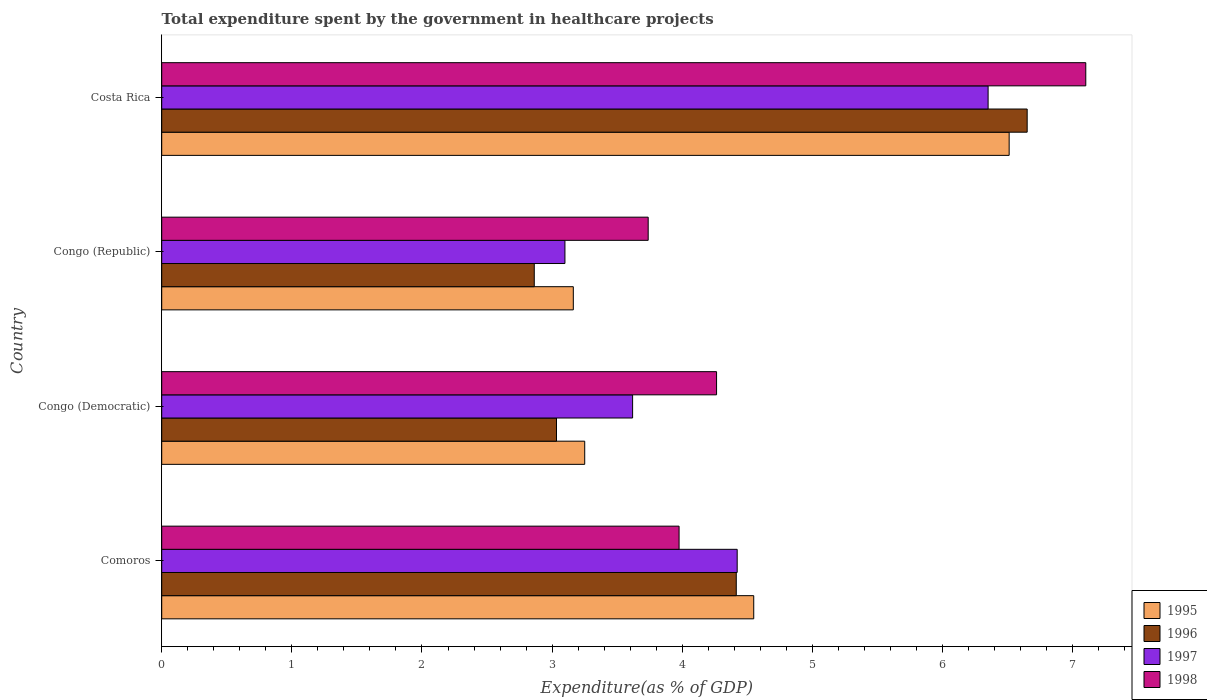How many different coloured bars are there?
Your response must be concise. 4. How many bars are there on the 3rd tick from the top?
Your answer should be compact. 4. How many bars are there on the 1st tick from the bottom?
Give a very brief answer. 4. What is the label of the 2nd group of bars from the top?
Keep it short and to the point. Congo (Republic). What is the total expenditure spent by the government in healthcare projects in 1995 in Congo (Democratic)?
Give a very brief answer. 3.25. Across all countries, what is the maximum total expenditure spent by the government in healthcare projects in 1998?
Give a very brief answer. 7.1. Across all countries, what is the minimum total expenditure spent by the government in healthcare projects in 1996?
Keep it short and to the point. 2.86. In which country was the total expenditure spent by the government in healthcare projects in 1995 maximum?
Provide a short and direct response. Costa Rica. In which country was the total expenditure spent by the government in healthcare projects in 1997 minimum?
Offer a terse response. Congo (Republic). What is the total total expenditure spent by the government in healthcare projects in 1996 in the graph?
Your answer should be compact. 16.96. What is the difference between the total expenditure spent by the government in healthcare projects in 1998 in Comoros and that in Costa Rica?
Your answer should be very brief. -3.13. What is the difference between the total expenditure spent by the government in healthcare projects in 1996 in Congo (Democratic) and the total expenditure spent by the government in healthcare projects in 1995 in Comoros?
Ensure brevity in your answer.  -1.52. What is the average total expenditure spent by the government in healthcare projects in 1996 per country?
Offer a terse response. 4.24. What is the difference between the total expenditure spent by the government in healthcare projects in 1998 and total expenditure spent by the government in healthcare projects in 1996 in Congo (Republic)?
Provide a succinct answer. 0.88. In how many countries, is the total expenditure spent by the government in healthcare projects in 1996 greater than 2.8 %?
Make the answer very short. 4. What is the ratio of the total expenditure spent by the government in healthcare projects in 1997 in Comoros to that in Congo (Republic)?
Your answer should be compact. 1.43. Is the difference between the total expenditure spent by the government in healthcare projects in 1998 in Congo (Democratic) and Costa Rica greater than the difference between the total expenditure spent by the government in healthcare projects in 1996 in Congo (Democratic) and Costa Rica?
Ensure brevity in your answer.  Yes. What is the difference between the highest and the second highest total expenditure spent by the government in healthcare projects in 1996?
Make the answer very short. 2.24. What is the difference between the highest and the lowest total expenditure spent by the government in healthcare projects in 1996?
Offer a terse response. 3.79. What does the 3rd bar from the bottom in Congo (Democratic) represents?
Provide a short and direct response. 1997. How many bars are there?
Your response must be concise. 16. What is the difference between two consecutive major ticks on the X-axis?
Your response must be concise. 1. How many legend labels are there?
Offer a terse response. 4. How are the legend labels stacked?
Offer a terse response. Vertical. What is the title of the graph?
Offer a terse response. Total expenditure spent by the government in healthcare projects. What is the label or title of the X-axis?
Your answer should be compact. Expenditure(as % of GDP). What is the label or title of the Y-axis?
Provide a succinct answer. Country. What is the Expenditure(as % of GDP) in 1995 in Comoros?
Provide a short and direct response. 4.55. What is the Expenditure(as % of GDP) in 1996 in Comoros?
Keep it short and to the point. 4.42. What is the Expenditure(as % of GDP) of 1997 in Comoros?
Ensure brevity in your answer.  4.42. What is the Expenditure(as % of GDP) in 1998 in Comoros?
Offer a terse response. 3.98. What is the Expenditure(as % of GDP) in 1995 in Congo (Democratic)?
Give a very brief answer. 3.25. What is the Expenditure(as % of GDP) of 1996 in Congo (Democratic)?
Keep it short and to the point. 3.03. What is the Expenditure(as % of GDP) in 1997 in Congo (Democratic)?
Make the answer very short. 3.62. What is the Expenditure(as % of GDP) in 1998 in Congo (Democratic)?
Offer a very short reply. 4.26. What is the Expenditure(as % of GDP) of 1995 in Congo (Republic)?
Your response must be concise. 3.16. What is the Expenditure(as % of GDP) of 1996 in Congo (Republic)?
Ensure brevity in your answer.  2.86. What is the Expenditure(as % of GDP) of 1997 in Congo (Republic)?
Provide a short and direct response. 3.1. What is the Expenditure(as % of GDP) in 1998 in Congo (Republic)?
Ensure brevity in your answer.  3.74. What is the Expenditure(as % of GDP) in 1995 in Costa Rica?
Keep it short and to the point. 6.51. What is the Expenditure(as % of GDP) of 1996 in Costa Rica?
Ensure brevity in your answer.  6.65. What is the Expenditure(as % of GDP) of 1997 in Costa Rica?
Provide a succinct answer. 6.35. What is the Expenditure(as % of GDP) in 1998 in Costa Rica?
Offer a terse response. 7.1. Across all countries, what is the maximum Expenditure(as % of GDP) of 1995?
Make the answer very short. 6.51. Across all countries, what is the maximum Expenditure(as % of GDP) of 1996?
Your answer should be compact. 6.65. Across all countries, what is the maximum Expenditure(as % of GDP) in 1997?
Offer a very short reply. 6.35. Across all countries, what is the maximum Expenditure(as % of GDP) of 1998?
Provide a short and direct response. 7.1. Across all countries, what is the minimum Expenditure(as % of GDP) of 1995?
Give a very brief answer. 3.16. Across all countries, what is the minimum Expenditure(as % of GDP) in 1996?
Give a very brief answer. 2.86. Across all countries, what is the minimum Expenditure(as % of GDP) of 1997?
Provide a short and direct response. 3.1. Across all countries, what is the minimum Expenditure(as % of GDP) of 1998?
Provide a short and direct response. 3.74. What is the total Expenditure(as % of GDP) in 1995 in the graph?
Provide a short and direct response. 17.48. What is the total Expenditure(as % of GDP) in 1996 in the graph?
Provide a short and direct response. 16.96. What is the total Expenditure(as % of GDP) in 1997 in the graph?
Keep it short and to the point. 17.49. What is the total Expenditure(as % of GDP) in 1998 in the graph?
Your answer should be compact. 19.08. What is the difference between the Expenditure(as % of GDP) in 1995 in Comoros and that in Congo (Democratic)?
Your answer should be compact. 1.3. What is the difference between the Expenditure(as % of GDP) of 1996 in Comoros and that in Congo (Democratic)?
Your answer should be compact. 1.38. What is the difference between the Expenditure(as % of GDP) in 1997 in Comoros and that in Congo (Democratic)?
Give a very brief answer. 0.8. What is the difference between the Expenditure(as % of GDP) of 1998 in Comoros and that in Congo (Democratic)?
Offer a terse response. -0.29. What is the difference between the Expenditure(as % of GDP) of 1995 in Comoros and that in Congo (Republic)?
Give a very brief answer. 1.39. What is the difference between the Expenditure(as % of GDP) of 1996 in Comoros and that in Congo (Republic)?
Your answer should be compact. 1.55. What is the difference between the Expenditure(as % of GDP) of 1997 in Comoros and that in Congo (Republic)?
Keep it short and to the point. 1.32. What is the difference between the Expenditure(as % of GDP) in 1998 in Comoros and that in Congo (Republic)?
Your answer should be very brief. 0.24. What is the difference between the Expenditure(as % of GDP) of 1995 in Comoros and that in Costa Rica?
Provide a short and direct response. -1.96. What is the difference between the Expenditure(as % of GDP) of 1996 in Comoros and that in Costa Rica?
Your answer should be compact. -2.24. What is the difference between the Expenditure(as % of GDP) of 1997 in Comoros and that in Costa Rica?
Make the answer very short. -1.93. What is the difference between the Expenditure(as % of GDP) in 1998 in Comoros and that in Costa Rica?
Your answer should be compact. -3.13. What is the difference between the Expenditure(as % of GDP) in 1995 in Congo (Democratic) and that in Congo (Republic)?
Keep it short and to the point. 0.09. What is the difference between the Expenditure(as % of GDP) in 1996 in Congo (Democratic) and that in Congo (Republic)?
Keep it short and to the point. 0.17. What is the difference between the Expenditure(as % of GDP) of 1997 in Congo (Democratic) and that in Congo (Republic)?
Provide a succinct answer. 0.52. What is the difference between the Expenditure(as % of GDP) of 1998 in Congo (Democratic) and that in Congo (Republic)?
Keep it short and to the point. 0.53. What is the difference between the Expenditure(as % of GDP) of 1995 in Congo (Democratic) and that in Costa Rica?
Ensure brevity in your answer.  -3.26. What is the difference between the Expenditure(as % of GDP) in 1996 in Congo (Democratic) and that in Costa Rica?
Keep it short and to the point. -3.62. What is the difference between the Expenditure(as % of GDP) of 1997 in Congo (Democratic) and that in Costa Rica?
Ensure brevity in your answer.  -2.73. What is the difference between the Expenditure(as % of GDP) in 1998 in Congo (Democratic) and that in Costa Rica?
Make the answer very short. -2.84. What is the difference between the Expenditure(as % of GDP) of 1995 in Congo (Republic) and that in Costa Rica?
Provide a succinct answer. -3.35. What is the difference between the Expenditure(as % of GDP) of 1996 in Congo (Republic) and that in Costa Rica?
Offer a very short reply. -3.79. What is the difference between the Expenditure(as % of GDP) of 1997 in Congo (Republic) and that in Costa Rica?
Your response must be concise. -3.25. What is the difference between the Expenditure(as % of GDP) in 1998 in Congo (Republic) and that in Costa Rica?
Your answer should be very brief. -3.36. What is the difference between the Expenditure(as % of GDP) of 1995 in Comoros and the Expenditure(as % of GDP) of 1996 in Congo (Democratic)?
Your answer should be very brief. 1.52. What is the difference between the Expenditure(as % of GDP) of 1995 in Comoros and the Expenditure(as % of GDP) of 1997 in Congo (Democratic)?
Provide a short and direct response. 0.93. What is the difference between the Expenditure(as % of GDP) of 1995 in Comoros and the Expenditure(as % of GDP) of 1998 in Congo (Democratic)?
Provide a succinct answer. 0.29. What is the difference between the Expenditure(as % of GDP) in 1996 in Comoros and the Expenditure(as % of GDP) in 1997 in Congo (Democratic)?
Ensure brevity in your answer.  0.8. What is the difference between the Expenditure(as % of GDP) of 1996 in Comoros and the Expenditure(as % of GDP) of 1998 in Congo (Democratic)?
Your response must be concise. 0.15. What is the difference between the Expenditure(as % of GDP) of 1997 in Comoros and the Expenditure(as % of GDP) of 1998 in Congo (Democratic)?
Offer a terse response. 0.16. What is the difference between the Expenditure(as % of GDP) in 1995 in Comoros and the Expenditure(as % of GDP) in 1996 in Congo (Republic)?
Give a very brief answer. 1.69. What is the difference between the Expenditure(as % of GDP) in 1995 in Comoros and the Expenditure(as % of GDP) in 1997 in Congo (Republic)?
Your answer should be compact. 1.45. What is the difference between the Expenditure(as % of GDP) of 1995 in Comoros and the Expenditure(as % of GDP) of 1998 in Congo (Republic)?
Ensure brevity in your answer.  0.81. What is the difference between the Expenditure(as % of GDP) in 1996 in Comoros and the Expenditure(as % of GDP) in 1997 in Congo (Republic)?
Offer a very short reply. 1.32. What is the difference between the Expenditure(as % of GDP) in 1996 in Comoros and the Expenditure(as % of GDP) in 1998 in Congo (Republic)?
Your answer should be very brief. 0.68. What is the difference between the Expenditure(as % of GDP) of 1997 in Comoros and the Expenditure(as % of GDP) of 1998 in Congo (Republic)?
Your answer should be compact. 0.68. What is the difference between the Expenditure(as % of GDP) in 1995 in Comoros and the Expenditure(as % of GDP) in 1996 in Costa Rica?
Your answer should be compact. -2.1. What is the difference between the Expenditure(as % of GDP) of 1995 in Comoros and the Expenditure(as % of GDP) of 1997 in Costa Rica?
Your answer should be compact. -1.8. What is the difference between the Expenditure(as % of GDP) in 1995 in Comoros and the Expenditure(as % of GDP) in 1998 in Costa Rica?
Make the answer very short. -2.55. What is the difference between the Expenditure(as % of GDP) in 1996 in Comoros and the Expenditure(as % of GDP) in 1997 in Costa Rica?
Ensure brevity in your answer.  -1.94. What is the difference between the Expenditure(as % of GDP) of 1996 in Comoros and the Expenditure(as % of GDP) of 1998 in Costa Rica?
Your response must be concise. -2.69. What is the difference between the Expenditure(as % of GDP) of 1997 in Comoros and the Expenditure(as % of GDP) of 1998 in Costa Rica?
Ensure brevity in your answer.  -2.68. What is the difference between the Expenditure(as % of GDP) of 1995 in Congo (Democratic) and the Expenditure(as % of GDP) of 1996 in Congo (Republic)?
Provide a succinct answer. 0.39. What is the difference between the Expenditure(as % of GDP) in 1995 in Congo (Democratic) and the Expenditure(as % of GDP) in 1997 in Congo (Republic)?
Your response must be concise. 0.15. What is the difference between the Expenditure(as % of GDP) of 1995 in Congo (Democratic) and the Expenditure(as % of GDP) of 1998 in Congo (Republic)?
Your answer should be compact. -0.49. What is the difference between the Expenditure(as % of GDP) in 1996 in Congo (Democratic) and the Expenditure(as % of GDP) in 1997 in Congo (Republic)?
Your answer should be very brief. -0.06. What is the difference between the Expenditure(as % of GDP) in 1996 in Congo (Democratic) and the Expenditure(as % of GDP) in 1998 in Congo (Republic)?
Offer a terse response. -0.7. What is the difference between the Expenditure(as % of GDP) in 1997 in Congo (Democratic) and the Expenditure(as % of GDP) in 1998 in Congo (Republic)?
Offer a very short reply. -0.12. What is the difference between the Expenditure(as % of GDP) in 1995 in Congo (Democratic) and the Expenditure(as % of GDP) in 1996 in Costa Rica?
Offer a terse response. -3.4. What is the difference between the Expenditure(as % of GDP) of 1995 in Congo (Democratic) and the Expenditure(as % of GDP) of 1997 in Costa Rica?
Give a very brief answer. -3.1. What is the difference between the Expenditure(as % of GDP) in 1995 in Congo (Democratic) and the Expenditure(as % of GDP) in 1998 in Costa Rica?
Offer a terse response. -3.85. What is the difference between the Expenditure(as % of GDP) in 1996 in Congo (Democratic) and the Expenditure(as % of GDP) in 1997 in Costa Rica?
Provide a succinct answer. -3.32. What is the difference between the Expenditure(as % of GDP) of 1996 in Congo (Democratic) and the Expenditure(as % of GDP) of 1998 in Costa Rica?
Your answer should be very brief. -4.07. What is the difference between the Expenditure(as % of GDP) in 1997 in Congo (Democratic) and the Expenditure(as % of GDP) in 1998 in Costa Rica?
Provide a succinct answer. -3.48. What is the difference between the Expenditure(as % of GDP) in 1995 in Congo (Republic) and the Expenditure(as % of GDP) in 1996 in Costa Rica?
Ensure brevity in your answer.  -3.49. What is the difference between the Expenditure(as % of GDP) in 1995 in Congo (Republic) and the Expenditure(as % of GDP) in 1997 in Costa Rica?
Your response must be concise. -3.19. What is the difference between the Expenditure(as % of GDP) of 1995 in Congo (Republic) and the Expenditure(as % of GDP) of 1998 in Costa Rica?
Make the answer very short. -3.94. What is the difference between the Expenditure(as % of GDP) in 1996 in Congo (Republic) and the Expenditure(as % of GDP) in 1997 in Costa Rica?
Your response must be concise. -3.49. What is the difference between the Expenditure(as % of GDP) of 1996 in Congo (Republic) and the Expenditure(as % of GDP) of 1998 in Costa Rica?
Your answer should be very brief. -4.24. What is the difference between the Expenditure(as % of GDP) of 1997 in Congo (Republic) and the Expenditure(as % of GDP) of 1998 in Costa Rica?
Your response must be concise. -4. What is the average Expenditure(as % of GDP) in 1995 per country?
Provide a short and direct response. 4.37. What is the average Expenditure(as % of GDP) in 1996 per country?
Your response must be concise. 4.24. What is the average Expenditure(as % of GDP) in 1997 per country?
Provide a short and direct response. 4.37. What is the average Expenditure(as % of GDP) in 1998 per country?
Keep it short and to the point. 4.77. What is the difference between the Expenditure(as % of GDP) in 1995 and Expenditure(as % of GDP) in 1996 in Comoros?
Your response must be concise. 0.13. What is the difference between the Expenditure(as % of GDP) of 1995 and Expenditure(as % of GDP) of 1997 in Comoros?
Keep it short and to the point. 0.13. What is the difference between the Expenditure(as % of GDP) of 1995 and Expenditure(as % of GDP) of 1998 in Comoros?
Offer a terse response. 0.57. What is the difference between the Expenditure(as % of GDP) in 1996 and Expenditure(as % of GDP) in 1997 in Comoros?
Your answer should be compact. -0.01. What is the difference between the Expenditure(as % of GDP) of 1996 and Expenditure(as % of GDP) of 1998 in Comoros?
Provide a succinct answer. 0.44. What is the difference between the Expenditure(as % of GDP) of 1997 and Expenditure(as % of GDP) of 1998 in Comoros?
Give a very brief answer. 0.45. What is the difference between the Expenditure(as % of GDP) in 1995 and Expenditure(as % of GDP) in 1996 in Congo (Democratic)?
Your answer should be compact. 0.22. What is the difference between the Expenditure(as % of GDP) of 1995 and Expenditure(as % of GDP) of 1997 in Congo (Democratic)?
Keep it short and to the point. -0.37. What is the difference between the Expenditure(as % of GDP) in 1995 and Expenditure(as % of GDP) in 1998 in Congo (Democratic)?
Offer a very short reply. -1.01. What is the difference between the Expenditure(as % of GDP) of 1996 and Expenditure(as % of GDP) of 1997 in Congo (Democratic)?
Provide a short and direct response. -0.58. What is the difference between the Expenditure(as % of GDP) of 1996 and Expenditure(as % of GDP) of 1998 in Congo (Democratic)?
Provide a succinct answer. -1.23. What is the difference between the Expenditure(as % of GDP) in 1997 and Expenditure(as % of GDP) in 1998 in Congo (Democratic)?
Give a very brief answer. -0.65. What is the difference between the Expenditure(as % of GDP) in 1995 and Expenditure(as % of GDP) in 1996 in Congo (Republic)?
Ensure brevity in your answer.  0.3. What is the difference between the Expenditure(as % of GDP) of 1995 and Expenditure(as % of GDP) of 1997 in Congo (Republic)?
Provide a short and direct response. 0.06. What is the difference between the Expenditure(as % of GDP) of 1995 and Expenditure(as % of GDP) of 1998 in Congo (Republic)?
Provide a succinct answer. -0.58. What is the difference between the Expenditure(as % of GDP) of 1996 and Expenditure(as % of GDP) of 1997 in Congo (Republic)?
Make the answer very short. -0.24. What is the difference between the Expenditure(as % of GDP) in 1996 and Expenditure(as % of GDP) in 1998 in Congo (Republic)?
Offer a terse response. -0.88. What is the difference between the Expenditure(as % of GDP) in 1997 and Expenditure(as % of GDP) in 1998 in Congo (Republic)?
Ensure brevity in your answer.  -0.64. What is the difference between the Expenditure(as % of GDP) of 1995 and Expenditure(as % of GDP) of 1996 in Costa Rica?
Your answer should be compact. -0.14. What is the difference between the Expenditure(as % of GDP) of 1995 and Expenditure(as % of GDP) of 1997 in Costa Rica?
Provide a succinct answer. 0.16. What is the difference between the Expenditure(as % of GDP) of 1995 and Expenditure(as % of GDP) of 1998 in Costa Rica?
Your answer should be very brief. -0.59. What is the difference between the Expenditure(as % of GDP) of 1996 and Expenditure(as % of GDP) of 1997 in Costa Rica?
Your answer should be compact. 0.3. What is the difference between the Expenditure(as % of GDP) in 1996 and Expenditure(as % of GDP) in 1998 in Costa Rica?
Offer a very short reply. -0.45. What is the difference between the Expenditure(as % of GDP) of 1997 and Expenditure(as % of GDP) of 1998 in Costa Rica?
Keep it short and to the point. -0.75. What is the ratio of the Expenditure(as % of GDP) of 1995 in Comoros to that in Congo (Democratic)?
Your response must be concise. 1.4. What is the ratio of the Expenditure(as % of GDP) of 1996 in Comoros to that in Congo (Democratic)?
Make the answer very short. 1.46. What is the ratio of the Expenditure(as % of GDP) of 1997 in Comoros to that in Congo (Democratic)?
Ensure brevity in your answer.  1.22. What is the ratio of the Expenditure(as % of GDP) in 1998 in Comoros to that in Congo (Democratic)?
Provide a short and direct response. 0.93. What is the ratio of the Expenditure(as % of GDP) of 1995 in Comoros to that in Congo (Republic)?
Keep it short and to the point. 1.44. What is the ratio of the Expenditure(as % of GDP) of 1996 in Comoros to that in Congo (Republic)?
Your answer should be compact. 1.54. What is the ratio of the Expenditure(as % of GDP) in 1997 in Comoros to that in Congo (Republic)?
Give a very brief answer. 1.43. What is the ratio of the Expenditure(as % of GDP) in 1998 in Comoros to that in Congo (Republic)?
Ensure brevity in your answer.  1.06. What is the ratio of the Expenditure(as % of GDP) of 1995 in Comoros to that in Costa Rica?
Ensure brevity in your answer.  0.7. What is the ratio of the Expenditure(as % of GDP) of 1996 in Comoros to that in Costa Rica?
Offer a very short reply. 0.66. What is the ratio of the Expenditure(as % of GDP) in 1997 in Comoros to that in Costa Rica?
Your answer should be very brief. 0.7. What is the ratio of the Expenditure(as % of GDP) in 1998 in Comoros to that in Costa Rica?
Make the answer very short. 0.56. What is the ratio of the Expenditure(as % of GDP) of 1995 in Congo (Democratic) to that in Congo (Republic)?
Keep it short and to the point. 1.03. What is the ratio of the Expenditure(as % of GDP) in 1996 in Congo (Democratic) to that in Congo (Republic)?
Your response must be concise. 1.06. What is the ratio of the Expenditure(as % of GDP) in 1997 in Congo (Democratic) to that in Congo (Republic)?
Your answer should be very brief. 1.17. What is the ratio of the Expenditure(as % of GDP) in 1998 in Congo (Democratic) to that in Congo (Republic)?
Your answer should be compact. 1.14. What is the ratio of the Expenditure(as % of GDP) of 1995 in Congo (Democratic) to that in Costa Rica?
Keep it short and to the point. 0.5. What is the ratio of the Expenditure(as % of GDP) in 1996 in Congo (Democratic) to that in Costa Rica?
Provide a short and direct response. 0.46. What is the ratio of the Expenditure(as % of GDP) in 1997 in Congo (Democratic) to that in Costa Rica?
Offer a terse response. 0.57. What is the ratio of the Expenditure(as % of GDP) of 1998 in Congo (Democratic) to that in Costa Rica?
Your answer should be compact. 0.6. What is the ratio of the Expenditure(as % of GDP) in 1995 in Congo (Republic) to that in Costa Rica?
Your response must be concise. 0.49. What is the ratio of the Expenditure(as % of GDP) of 1996 in Congo (Republic) to that in Costa Rica?
Your answer should be very brief. 0.43. What is the ratio of the Expenditure(as % of GDP) in 1997 in Congo (Republic) to that in Costa Rica?
Keep it short and to the point. 0.49. What is the ratio of the Expenditure(as % of GDP) in 1998 in Congo (Republic) to that in Costa Rica?
Your response must be concise. 0.53. What is the difference between the highest and the second highest Expenditure(as % of GDP) of 1995?
Offer a terse response. 1.96. What is the difference between the highest and the second highest Expenditure(as % of GDP) of 1996?
Your answer should be very brief. 2.24. What is the difference between the highest and the second highest Expenditure(as % of GDP) in 1997?
Give a very brief answer. 1.93. What is the difference between the highest and the second highest Expenditure(as % of GDP) in 1998?
Provide a succinct answer. 2.84. What is the difference between the highest and the lowest Expenditure(as % of GDP) of 1995?
Provide a short and direct response. 3.35. What is the difference between the highest and the lowest Expenditure(as % of GDP) in 1996?
Your answer should be compact. 3.79. What is the difference between the highest and the lowest Expenditure(as % of GDP) of 1997?
Provide a succinct answer. 3.25. What is the difference between the highest and the lowest Expenditure(as % of GDP) of 1998?
Provide a short and direct response. 3.36. 